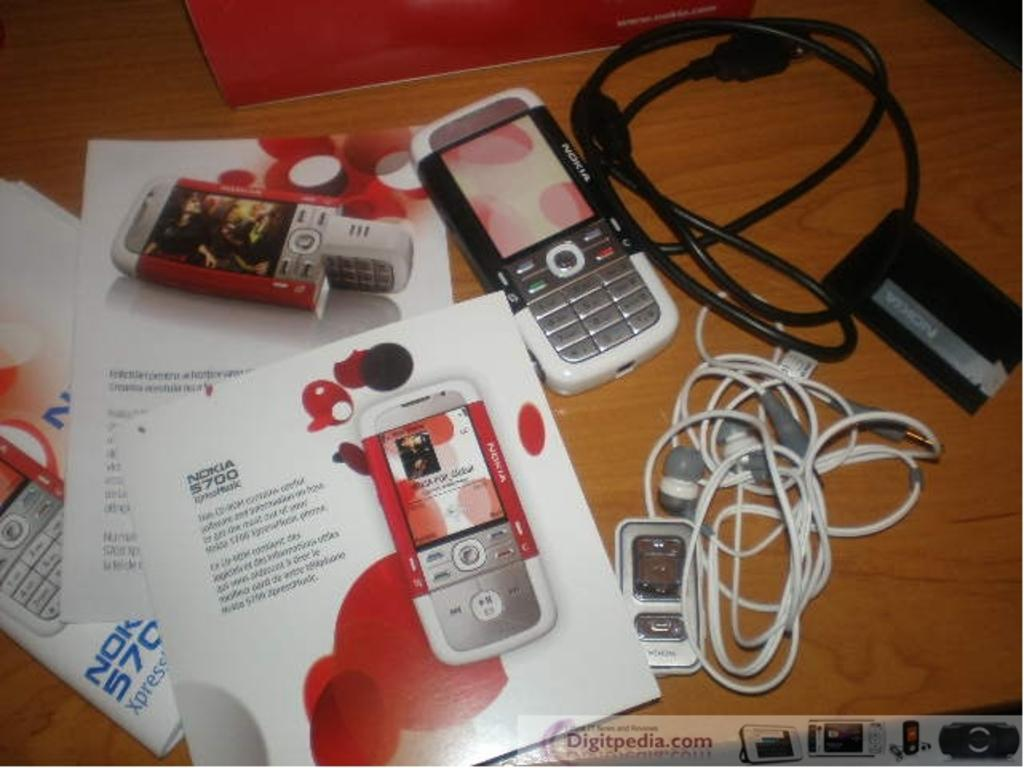Provide a one-sentence caption for the provided image. The new Nokia phone has many different features and is in red and white. 